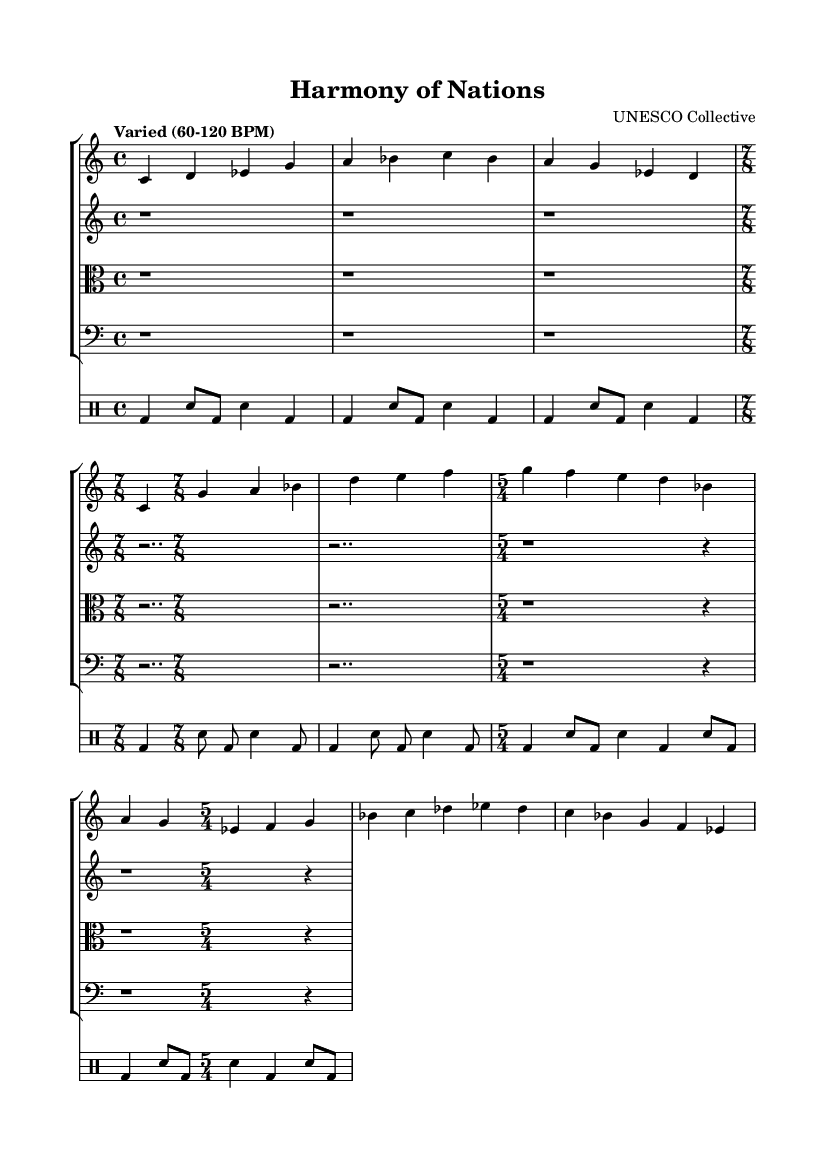What is the time signature of the main theme? The main theme is in 4/4 time signature, as indicated at the beginning of the score.
Answer: 4/4 What is the tempo marking indicated in the score? The tempo marking states "Varied (60-120 BPM)", suggesting that the tempo can fluctuate within that range.
Answer: Varied (60-120 BPM) How many measures are there in the djembe part? Counting the measures in the djembe part yields a total of 12 measures.
Answer: 12 What is the rhythmic pattern in the djembe part? The djembe part features a repetitive pattern with kick drum and snare drum, alternating and varied throughout the measures, clearly visible in the drum notation.
Answer: Kick and snare pattern What is the significance of the time signature changes in the piece? The score features changes in time signatures to create diverse rhythmic feels; for example, it shifts from 4/4 to 7/8 and 5/4, enhancing the experimental aspect of the orchestral work.
Answer: Diverse rhythmic feels Which instruments are involved in the orchestration of this work? The orchestration includes two violins, viola, cello, and djembe, with each instrument playing specific parts indicated in the score.
Answer: Violins, viola, cello, djembe What can be inferred about the cultural diversity represented in this piece? The inclusion of traditional instruments like the djembe alongside classical strings signifies intercultural dialogue, blending different musical languages and traditions.
Answer: Intercultural dialogue 